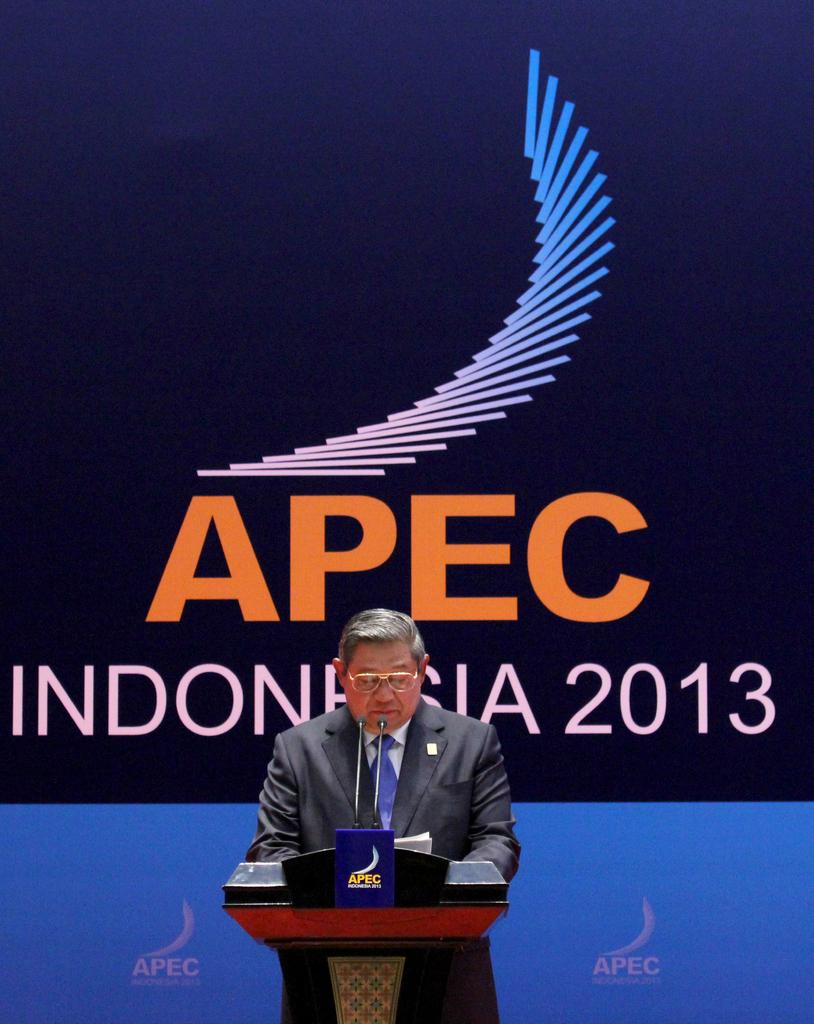Provide a one-sentence caption for the provided image. A man is speaking at a podium at APEC Indonesia 2013. 